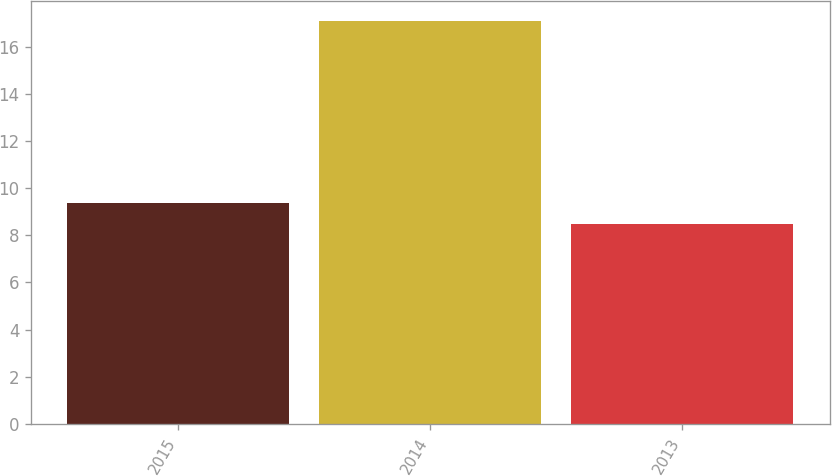Convert chart to OTSL. <chart><loc_0><loc_0><loc_500><loc_500><bar_chart><fcel>2015<fcel>2014<fcel>2013<nl><fcel>9.36<fcel>17.1<fcel>8.5<nl></chart> 